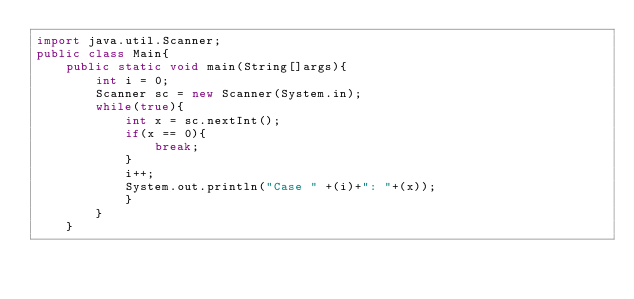<code> <loc_0><loc_0><loc_500><loc_500><_Java_>import java.util.Scanner;
public class Main{
	public static void main(String[]args){
		int i = 0;
		Scanner sc = new Scanner(System.in);
		while(true){
			int x = sc.nextInt();
			if(x == 0){
				break;
			}
			i++;
			System.out.println("Case " +(i)+": "+(x));
			}
		}
	}</code> 